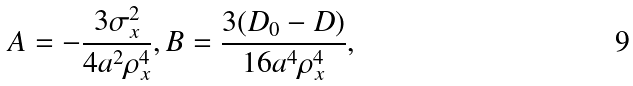Convert formula to latex. <formula><loc_0><loc_0><loc_500><loc_500>A = - \frac { 3 \sigma _ { x } ^ { 2 } } { 4 a ^ { 2 } \rho _ { x } ^ { 4 } } , B = \frac { 3 ( D _ { 0 } - D ) } { 1 6 a ^ { 4 } \rho _ { x } ^ { 4 } } ,</formula> 